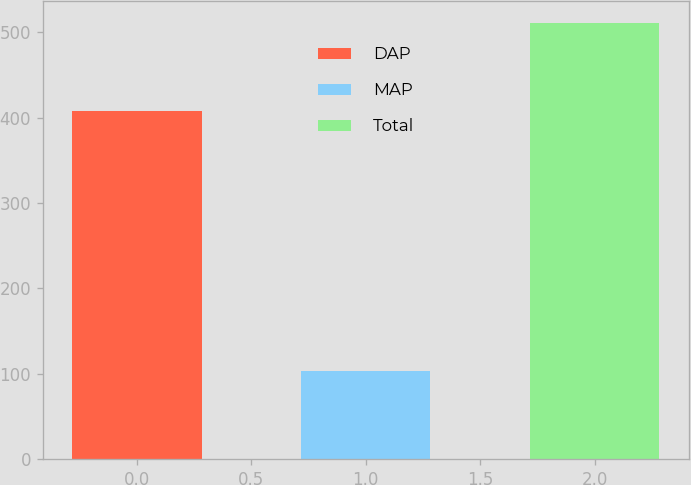<chart> <loc_0><loc_0><loc_500><loc_500><bar_chart><fcel>DAP<fcel>MAP<fcel>Total<nl><fcel>407.3<fcel>103.7<fcel>511<nl></chart> 